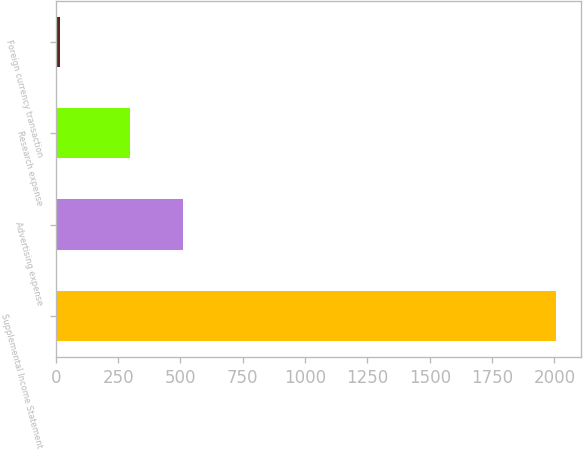Convert chart to OTSL. <chart><loc_0><loc_0><loc_500><loc_500><bar_chart><fcel>Supplemental Income Statement<fcel>Advertising expense<fcel>Research expense<fcel>Foreign currency transaction<nl><fcel>2008<fcel>512<fcel>297<fcel>18<nl></chart> 